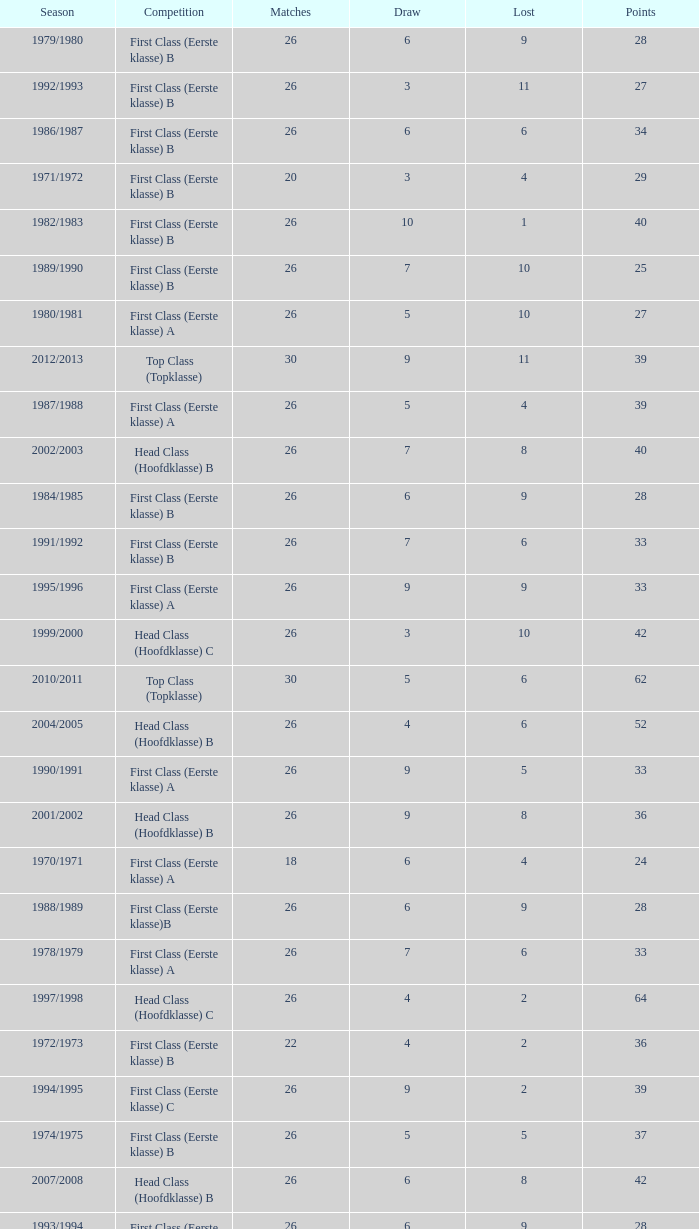Could you parse the entire table as a dict? {'header': ['Season', 'Competition', 'Matches', 'Draw', 'Lost', 'Points'], 'rows': [['1979/1980', 'First Class (Eerste klasse) B', '26', '6', '9', '28'], ['1992/1993', 'First Class (Eerste klasse) B', '26', '3', '11', '27'], ['1986/1987', 'First Class (Eerste klasse) B', '26', '6', '6', '34'], ['1971/1972', 'First Class (Eerste klasse) B', '20', '3', '4', '29'], ['1982/1983', 'First Class (Eerste klasse) B', '26', '10', '1', '40'], ['1989/1990', 'First Class (Eerste klasse) B', '26', '7', '10', '25'], ['1980/1981', 'First Class (Eerste klasse) A', '26', '5', '10', '27'], ['2012/2013', 'Top Class (Topklasse)', '30', '9', '11', '39'], ['1987/1988', 'First Class (Eerste klasse) A', '26', '5', '4', '39'], ['2002/2003', 'Head Class (Hoofdklasse) B', '26', '7', '8', '40'], ['1984/1985', 'First Class (Eerste klasse) B', '26', '6', '9', '28'], ['1991/1992', 'First Class (Eerste klasse) B', '26', '7', '6', '33'], ['1995/1996', 'First Class (Eerste klasse) A', '26', '9', '9', '33'], ['1999/2000', 'Head Class (Hoofdklasse) C', '26', '3', '10', '42'], ['2010/2011', 'Top Class (Topklasse)', '30', '5', '6', '62'], ['2004/2005', 'Head Class (Hoofdklasse) B', '26', '4', '6', '52'], ['1990/1991', 'First Class (Eerste klasse) A', '26', '9', '5', '33'], ['2001/2002', 'Head Class (Hoofdklasse) B', '26', '9', '8', '36'], ['1970/1971', 'First Class (Eerste klasse) A', '18', '6', '4', '24'], ['1988/1989', 'First Class (Eerste klasse)B', '26', '6', '9', '28'], ['1978/1979', 'First Class (Eerste klasse) A', '26', '7', '6', '33'], ['1997/1998', 'Head Class (Hoofdklasse) C', '26', '4', '2', '64'], ['1972/1973', 'First Class (Eerste klasse) B', '22', '4', '2', '36'], ['1994/1995', 'First Class (Eerste klasse) C', '26', '9', '2', '39'], ['1974/1975', 'First Class (Eerste klasse) B', '26', '5', '5', '37'], ['2007/2008', 'Head Class (Hoofdklasse) B', '26', '6', '8', '42'], ['1993/1994', 'First Class (Eerste klasse) B', '26', '6', '9', '28'], ['1998/1999', 'Head Class (Hoofdklasse) C', '26', '5', '3', '59'], ['1976/1977', 'First Class (Eerste klasse) B', '26', '7', '3', '39'], ['2003/2004', 'Head Class (Hoofdklasse) B', '24', '2', '5', '53'], ['2013/2014', 'Top Class (Topklasse)', '0', '0', '0', '0'], ['1981/1982', 'First Class (Eerste klasse) B', '26', '8', '3', '38'], ['1975/1976', 'First Class (Eerste klasse)B', '26', '5', '3', '41'], ['1983/1984', 'First Class (Eerste klasse) C', '26', '5', '3', '37'], ['1977/1978', 'First Class (Eerste klasse) A', '26', '6', '8', '30'], ['2011/2012', 'Top Class (Topklasse)', '30', '3', '12', '48'], ['1985/1986', 'First Class (Eerste klasse) B', '26', '7', '3', '39'], ['2008/2009', 'Head Class (Hoofdklasse) B', '26', '9', '2', '54'], ['1996/1997', 'Head Class (Hoofdklasse) B', '26', '7', '7', '43'], ['1973/1974', 'First Class (Eerste klasse)A', '22', '6', '4', '30'], ['2009/2010', 'Head Class (Hoofdklasse) B', '26', '3', '4', '60'], ['2000/2001', 'Head Class (Hoofdklasse) C', '26', '6', '12', '30'], ['2006/2007', 'Head Class (Hoofdklasse) B', '26', '5', '3', '59'], ['2005/2006', 'Head Class (Hoofdklasse) B', '26', '3', '5', '57']]} What competition has a score greater than 30, a draw less than 5, and a loss larger than 10? Top Class (Topklasse). 